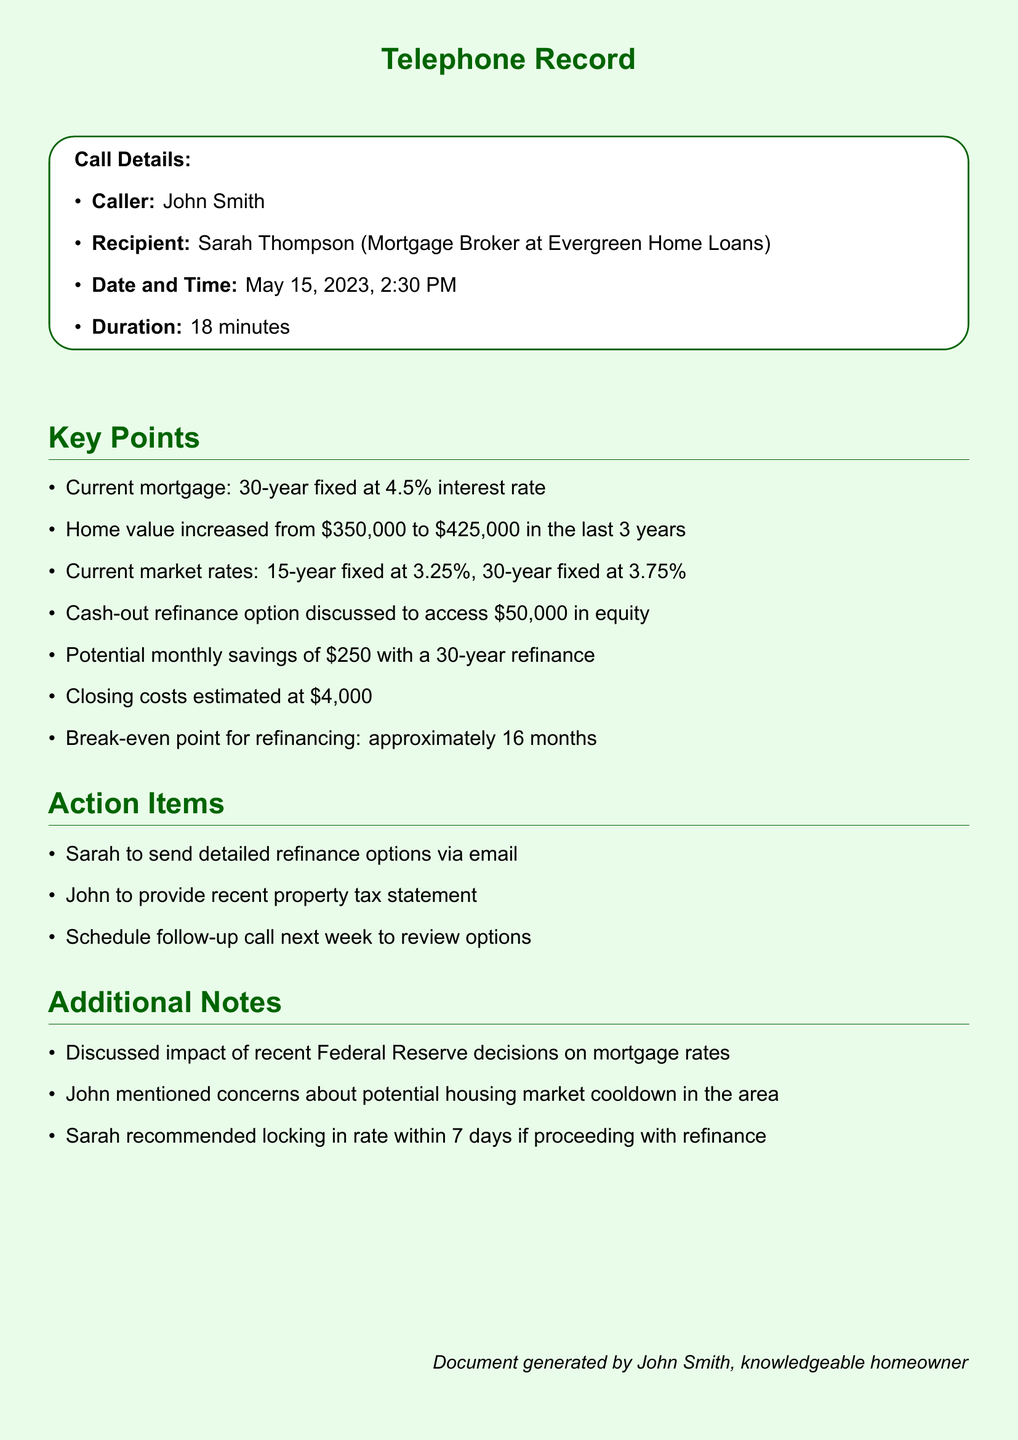What is the caller's name? The caller's name is listed in the call details section of the document as John Smith.
Answer: John Smith Who is the mortgage broker? The recipient of the call, the mortgage broker, is identified as Sarah Thompson.
Answer: Sarah Thompson What is the current mortgage interest rate? The current mortgage interest rate mentioned is 4.5%.
Answer: 4.5% How much has the home value increased in the last 3 years? The document states that the home value has increased from $350,000 to $425,000, which is a change of $75,000.
Answer: $75,000 What are the current market rates for a 30-year fixed mortgage? The current market rate for a 30-year fixed mortgage listed in the document is 3.75%.
Answer: 3.75% What type of refinance option was discussed? The document mentions a cash-out refinance option to access equity.
Answer: Cash-out refinance What are the estimated closing costs? The estimated closing costs provided in the conversation are $4,000.
Answer: $4,000 How long is the break-even point for refinancing? The break-even point for refinancing is specified as approximately 16 months.
Answer: 16 months What action did Sarah agree to take after the call? Sarah agreed to send detailed refinance options via email as an action item from the conversation.
Answer: Send detailed refinance options via email 